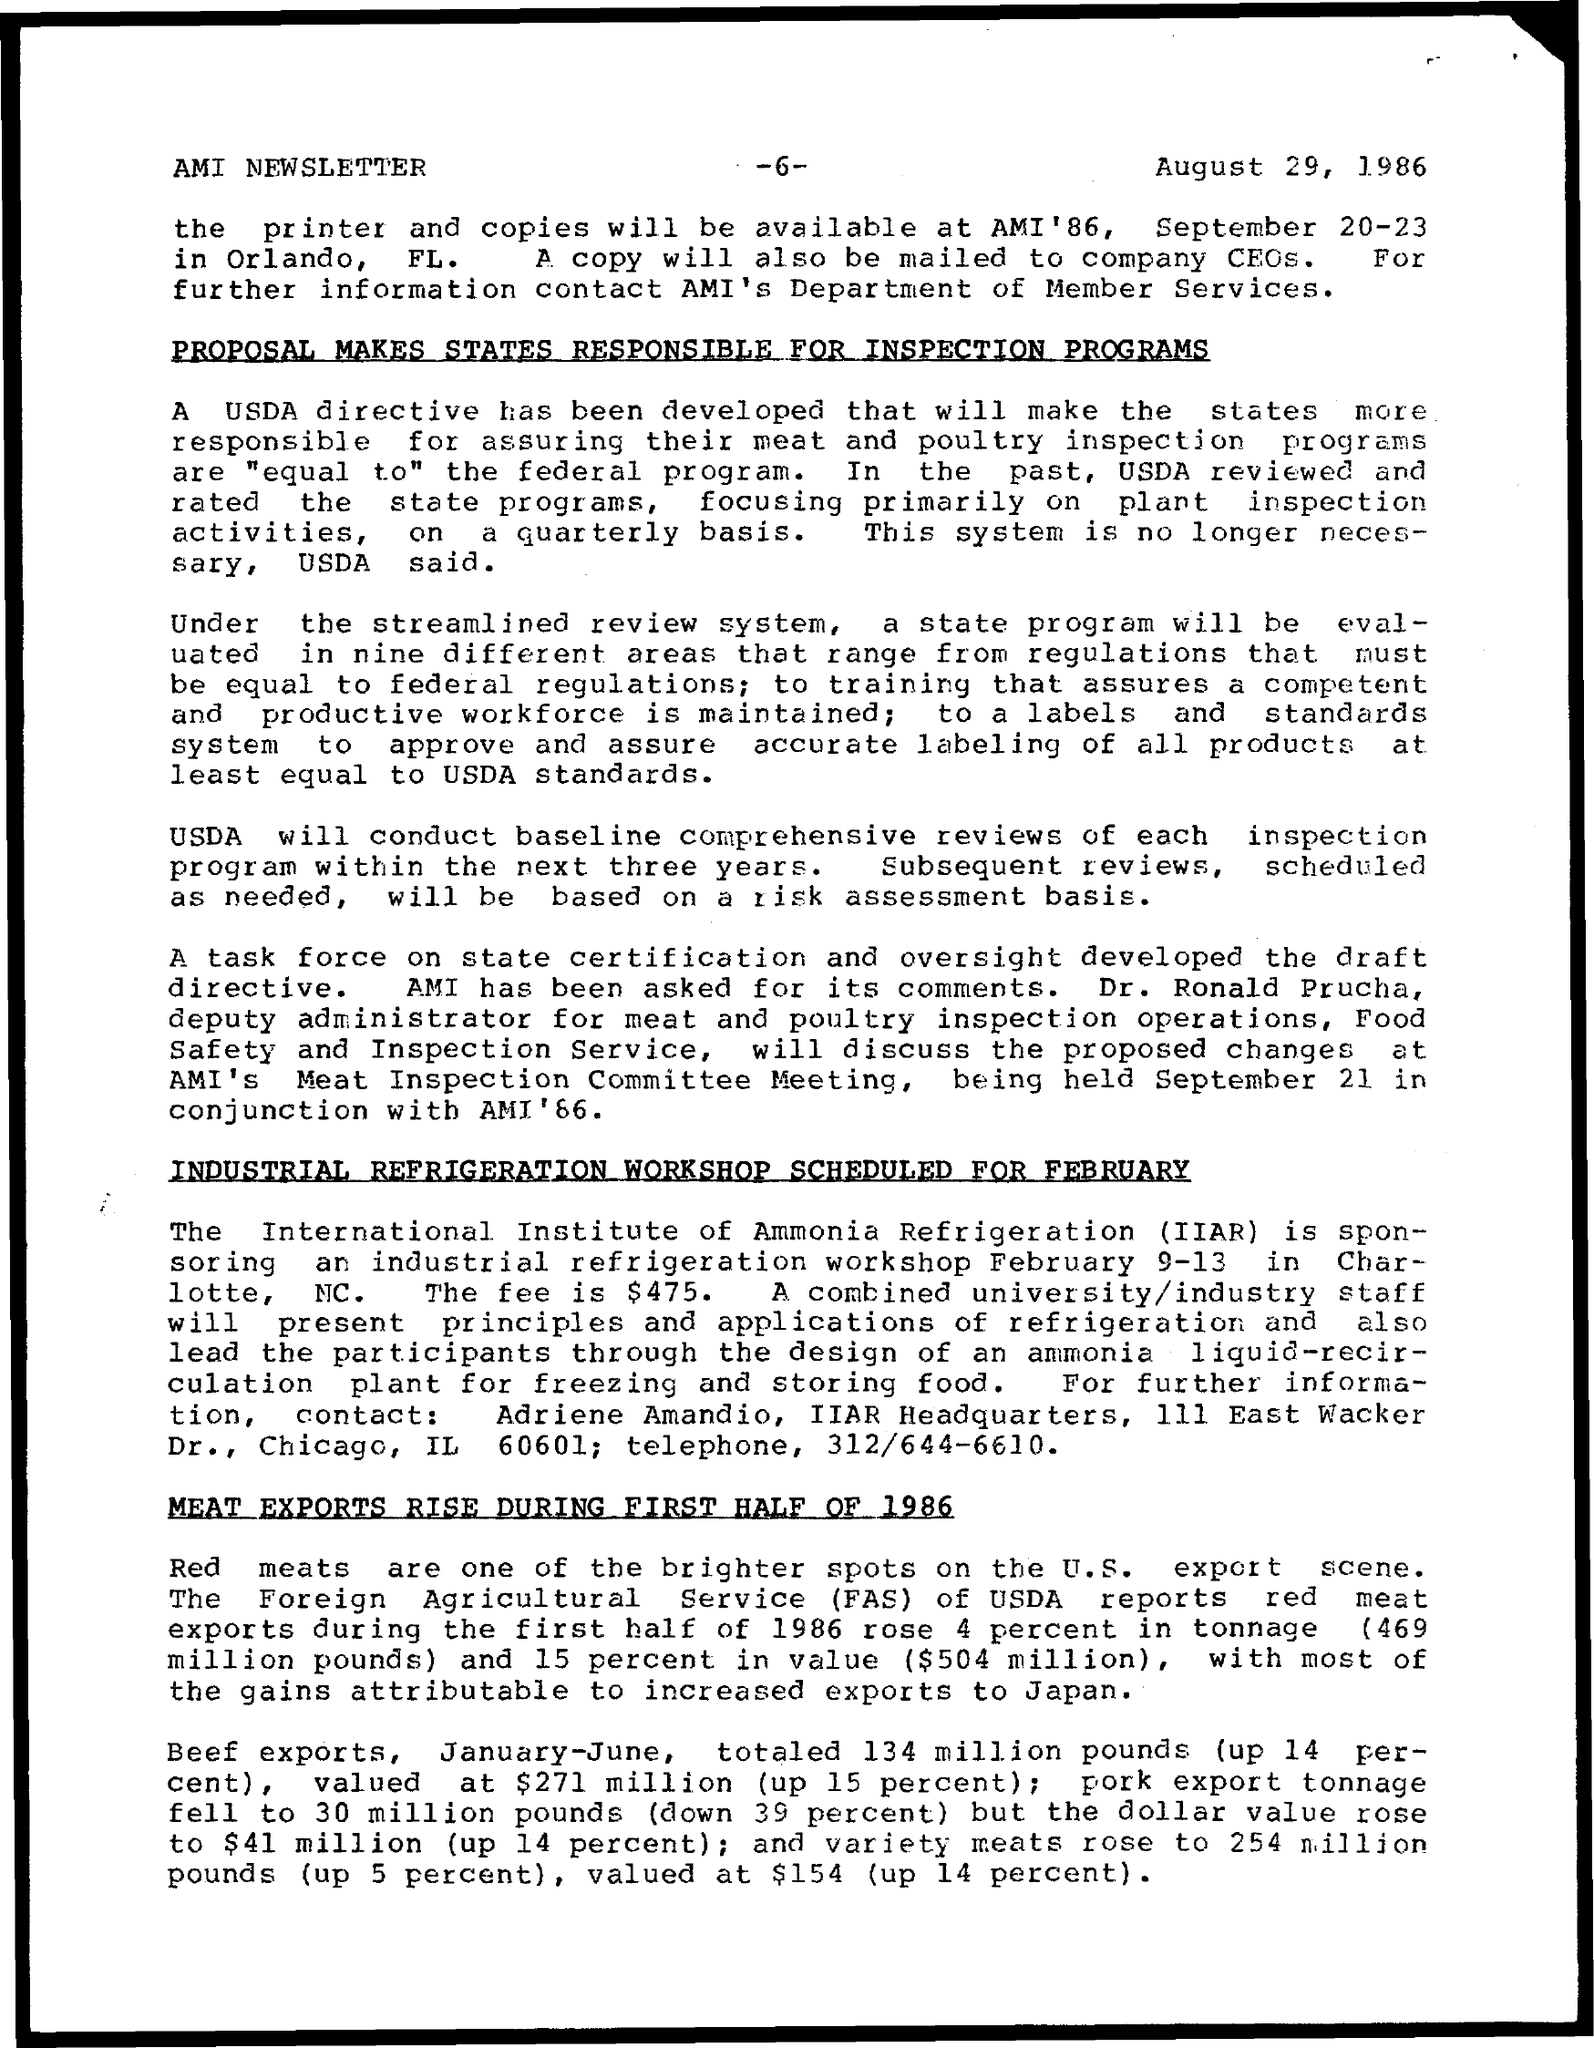Mention a couple of crucial points in this snapshot. The Industrial refrigeration workshop is scheduled for February. 